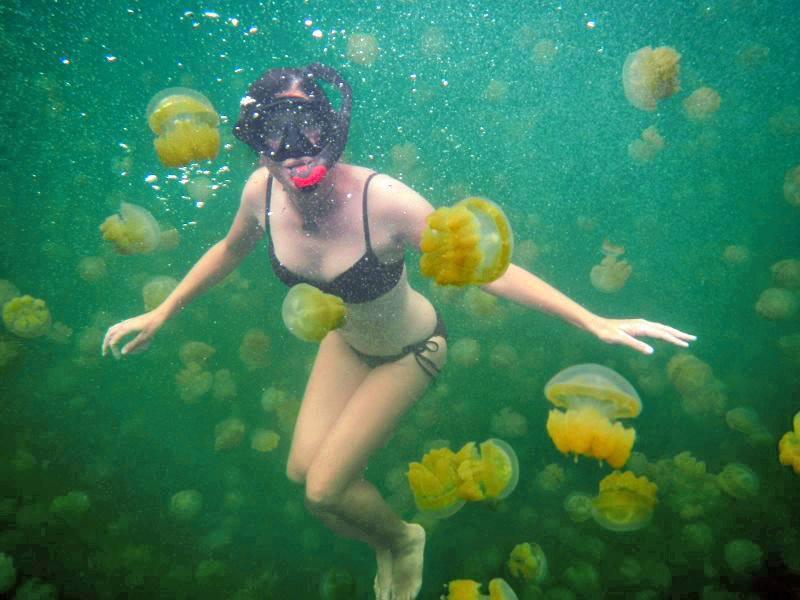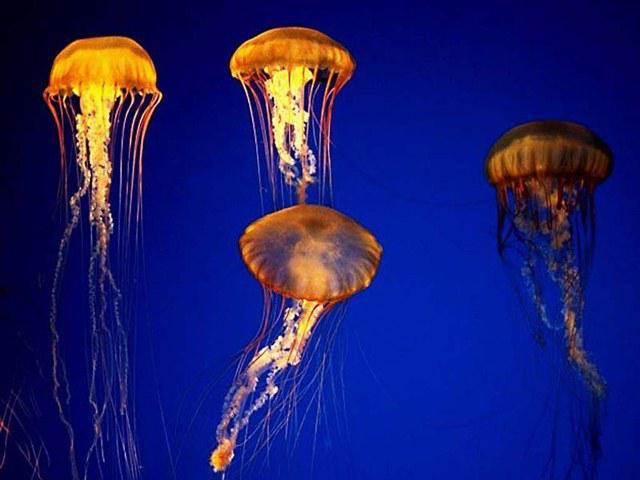The first image is the image on the left, the second image is the image on the right. For the images shown, is this caption "At least one jellyfish has tentacles longer than its body." true? Answer yes or no. Yes. The first image is the image on the left, the second image is the image on the right. Given the left and right images, does the statement "Neon pink jellyfish are shown in the right image." hold true? Answer yes or no. No. 